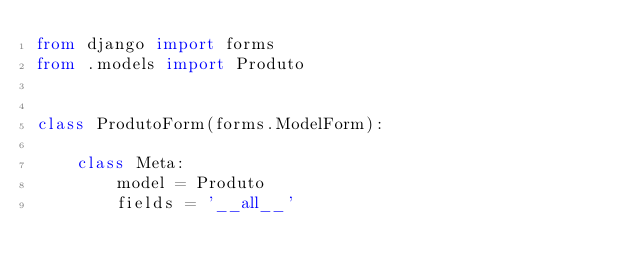<code> <loc_0><loc_0><loc_500><loc_500><_Python_>from django import forms
from .models import Produto


class ProdutoForm(forms.ModelForm):

    class Meta:
        model = Produto
        fields = '__all__'
</code> 